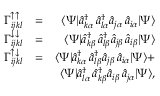Convert formula to latex. <formula><loc_0><loc_0><loc_500><loc_500>\begin{array} { r l r } { \Gamma _ { i j k l } ^ { \uparrow \uparrow } } & { = } & { \langle \Psi | \hat { a } _ { k \alpha } ^ { \dagger } \, \hat { a } _ { l \alpha } ^ { \dagger } \hat { a } _ { j \alpha } \, \hat { a } _ { i \alpha } | \Psi \rangle } \\ { \Gamma _ { i j k l } ^ { \downarrow \downarrow } } & { = } & { \langle \Psi | \hat { a } _ { k \beta } ^ { \dagger } \, \hat { a } _ { l \beta } ^ { \dagger } \hat { a } _ { j \beta } \, \hat { a } _ { i \beta } | \Psi \rangle } \\ { \Gamma _ { i j k l } ^ { \uparrow \downarrow } } & { = } & { \langle \Psi | \hat { a } _ { k \alpha } ^ { \dagger } \, \hat { a } _ { l \beta } ^ { \dagger } \hat { a } _ { j \beta } \, \hat { a } _ { i \alpha } | \Psi \rangle + } \\ & { \langle \Psi | \hat { a } _ { l \alpha } ^ { \dagger } \, \hat { a } _ { k \beta } ^ { \dagger } \hat { a } _ { i \beta } \, \hat { a } _ { j \alpha } | \Psi \rangle , } \end{array}</formula> 